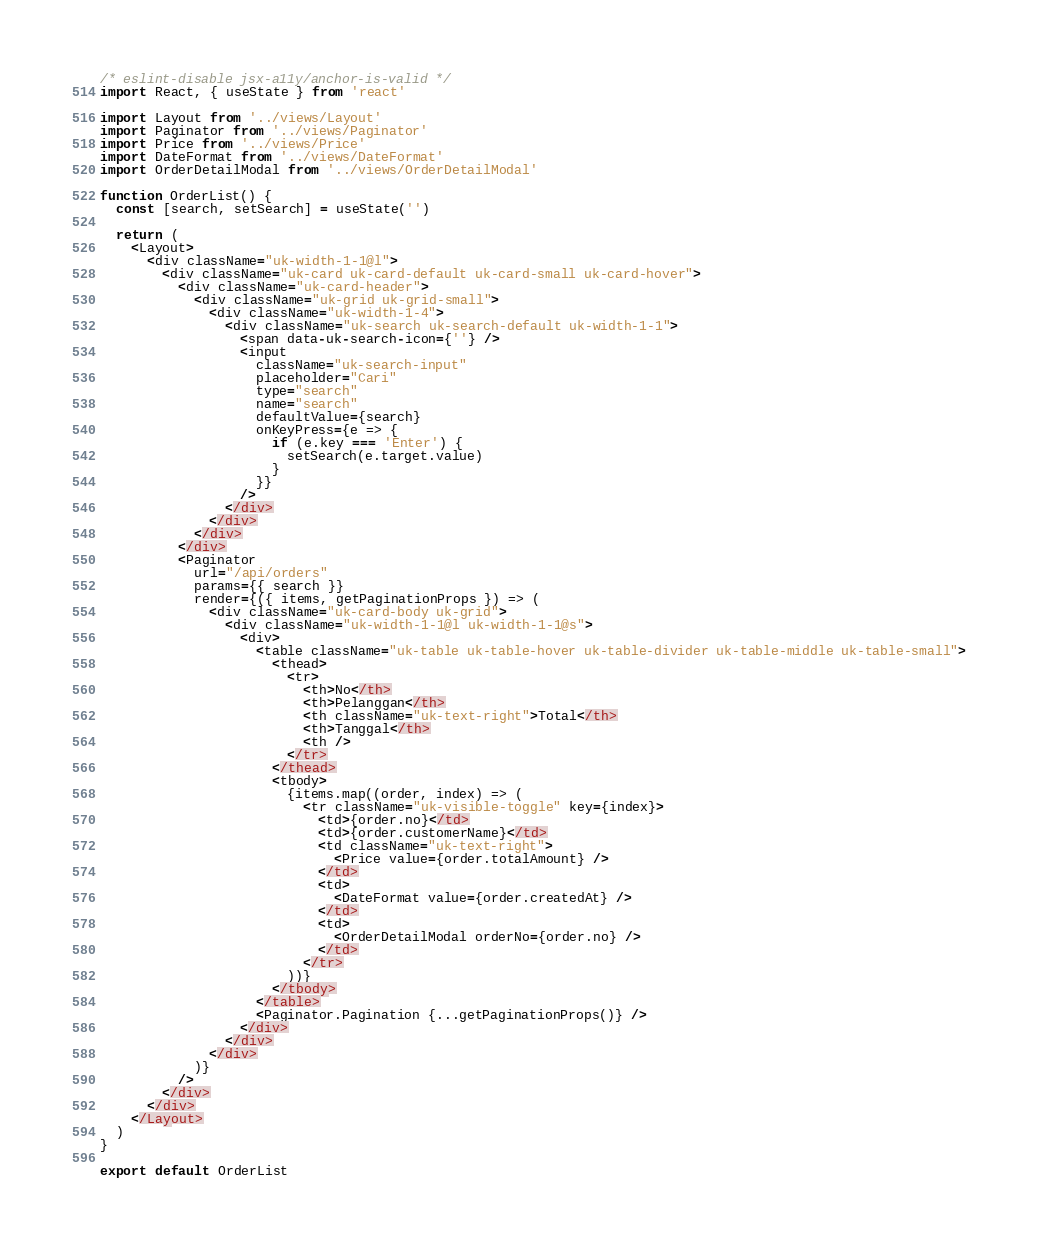Convert code to text. <code><loc_0><loc_0><loc_500><loc_500><_JavaScript_>/* eslint-disable jsx-a11y/anchor-is-valid */
import React, { useState } from 'react'

import Layout from '../views/Layout'
import Paginator from '../views/Paginator'
import Price from '../views/Price'
import DateFormat from '../views/DateFormat'
import OrderDetailModal from '../views/OrderDetailModal'

function OrderList() {
  const [search, setSearch] = useState('')

  return (
    <Layout>
      <div className="uk-width-1-1@l">
        <div className="uk-card uk-card-default uk-card-small uk-card-hover">
          <div className="uk-card-header">
            <div className="uk-grid uk-grid-small">
              <div className="uk-width-1-4">
                <div className="uk-search uk-search-default uk-width-1-1">
                  <span data-uk-search-icon={''} />
                  <input
                    className="uk-search-input"
                    placeholder="Cari"
                    type="search"
                    name="search"
                    defaultValue={search}
                    onKeyPress={e => {
                      if (e.key === 'Enter') {
                        setSearch(e.target.value)
                      }
                    }}
                  />
                </div>
              </div>
            </div>
          </div>
          <Paginator
            url="/api/orders"
            params={{ search }}
            render={({ items, getPaginationProps }) => (
              <div className="uk-card-body uk-grid">
                <div className="uk-width-1-1@l uk-width-1-1@s">
                  <div>
                    <table className="uk-table uk-table-hover uk-table-divider uk-table-middle uk-table-small">
                      <thead>
                        <tr>
                          <th>No</th>
                          <th>Pelanggan</th>
                          <th className="uk-text-right">Total</th>
                          <th>Tanggal</th>
                          <th />
                        </tr>
                      </thead>
                      <tbody>
                        {items.map((order, index) => (
                          <tr className="uk-visible-toggle" key={index}>
                            <td>{order.no}</td>
                            <td>{order.customerName}</td>
                            <td className="uk-text-right">
                              <Price value={order.totalAmount} />
                            </td>
                            <td>
                              <DateFormat value={order.createdAt} />
                            </td>
                            <td>
                              <OrderDetailModal orderNo={order.no} />
                            </td>
                          </tr>
                        ))}
                      </tbody>
                    </table>
                    <Paginator.Pagination {...getPaginationProps()} />
                  </div>
                </div>
              </div>
            )}
          />
        </div>
      </div>
    </Layout>
  )
}

export default OrderList
</code> 